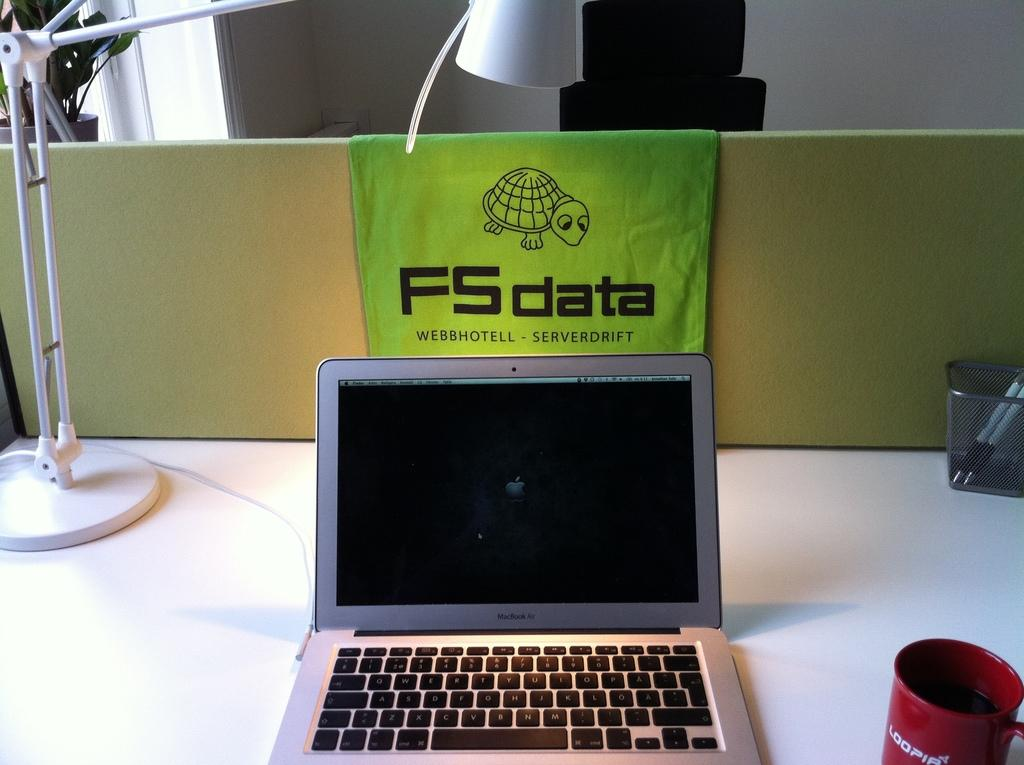<image>
Render a clear and concise summary of the photo. A laptop with a picture of a turtle saying FSdata in front 